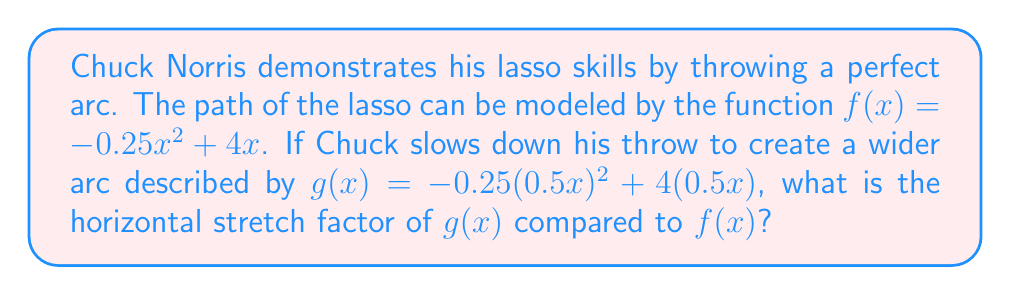Solve this math problem. 1. Let's compare the general forms of $f(x)$ and $g(x)$:
   $f(x) = -0.25x^2 + 4x$
   $g(x) = -0.25(0.5x)^2 + 4(0.5x)$

2. The horizontal stretch factor is the reciprocal of the factor inside the parentheses. In this case, it's $\frac{1}{0.5}$.

3. To verify, let's expand $g(x)$:
   $g(x) = -0.25(0.5x)^2 + 4(0.5x)$
   $= -0.25(0.25x^2) + 2x$
   $= -0.0625x^2 + 2x$

4. Now, let's apply a horizontal stretch of $2$ (which is $\frac{1}{0.5}$) to $f(x)$:
   $f(\frac{1}{2}x) = -0.25(\frac{1}{2}x)^2 + 4(\frac{1}{2}x)$
   $= -0.25(\frac{1}{4}x^2) + 2x$
   $= -0.0625x^2 + 2x$

5. We can see that $f(\frac{1}{2}x) = g(x)$, confirming the horizontal stretch factor.
Answer: 2 